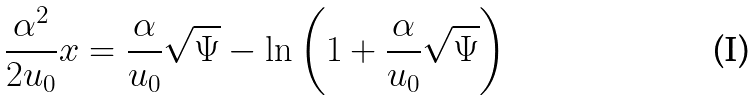Convert formula to latex. <formula><loc_0><loc_0><loc_500><loc_500>\frac { \alpha ^ { 2 } } { 2 u _ { 0 } } x = \frac { \alpha } { u _ { 0 } } \sqrt { \Psi } - \ln \left ( 1 + \frac { \alpha } { u _ { 0 } } \sqrt { \Psi } \right )</formula> 